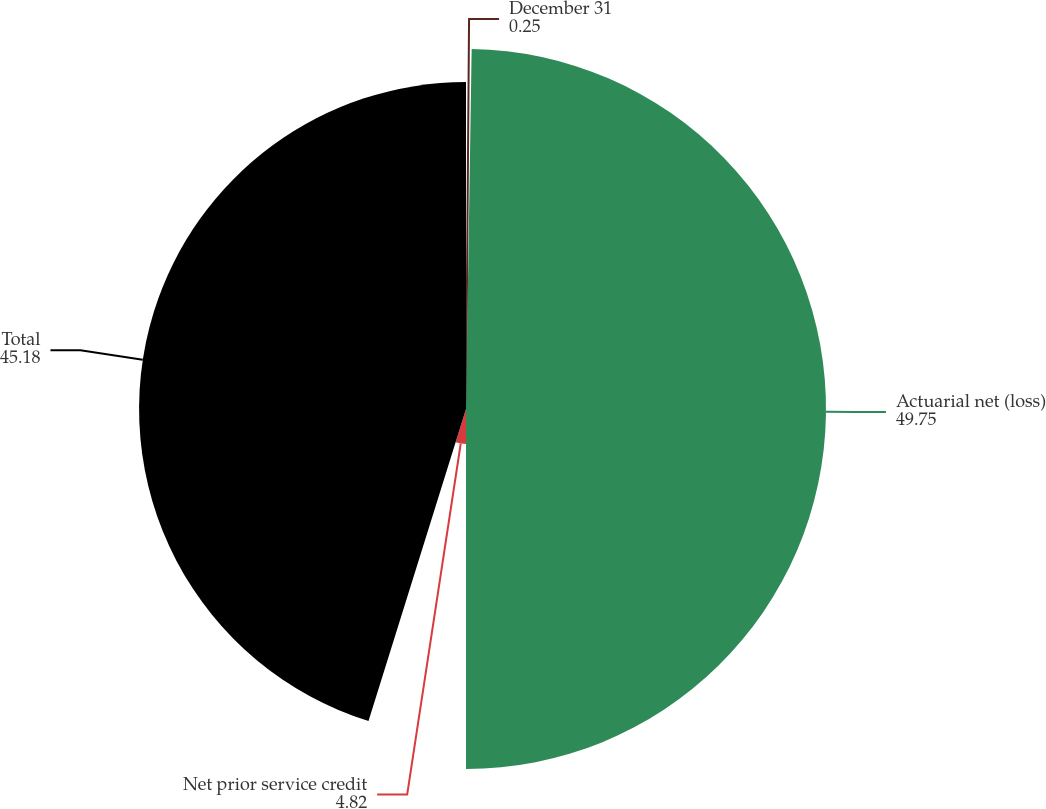Convert chart to OTSL. <chart><loc_0><loc_0><loc_500><loc_500><pie_chart><fcel>December 31<fcel>Actuarial net (loss)<fcel>Net prior service credit<fcel>Total<nl><fcel>0.25%<fcel>49.75%<fcel>4.82%<fcel>45.18%<nl></chart> 